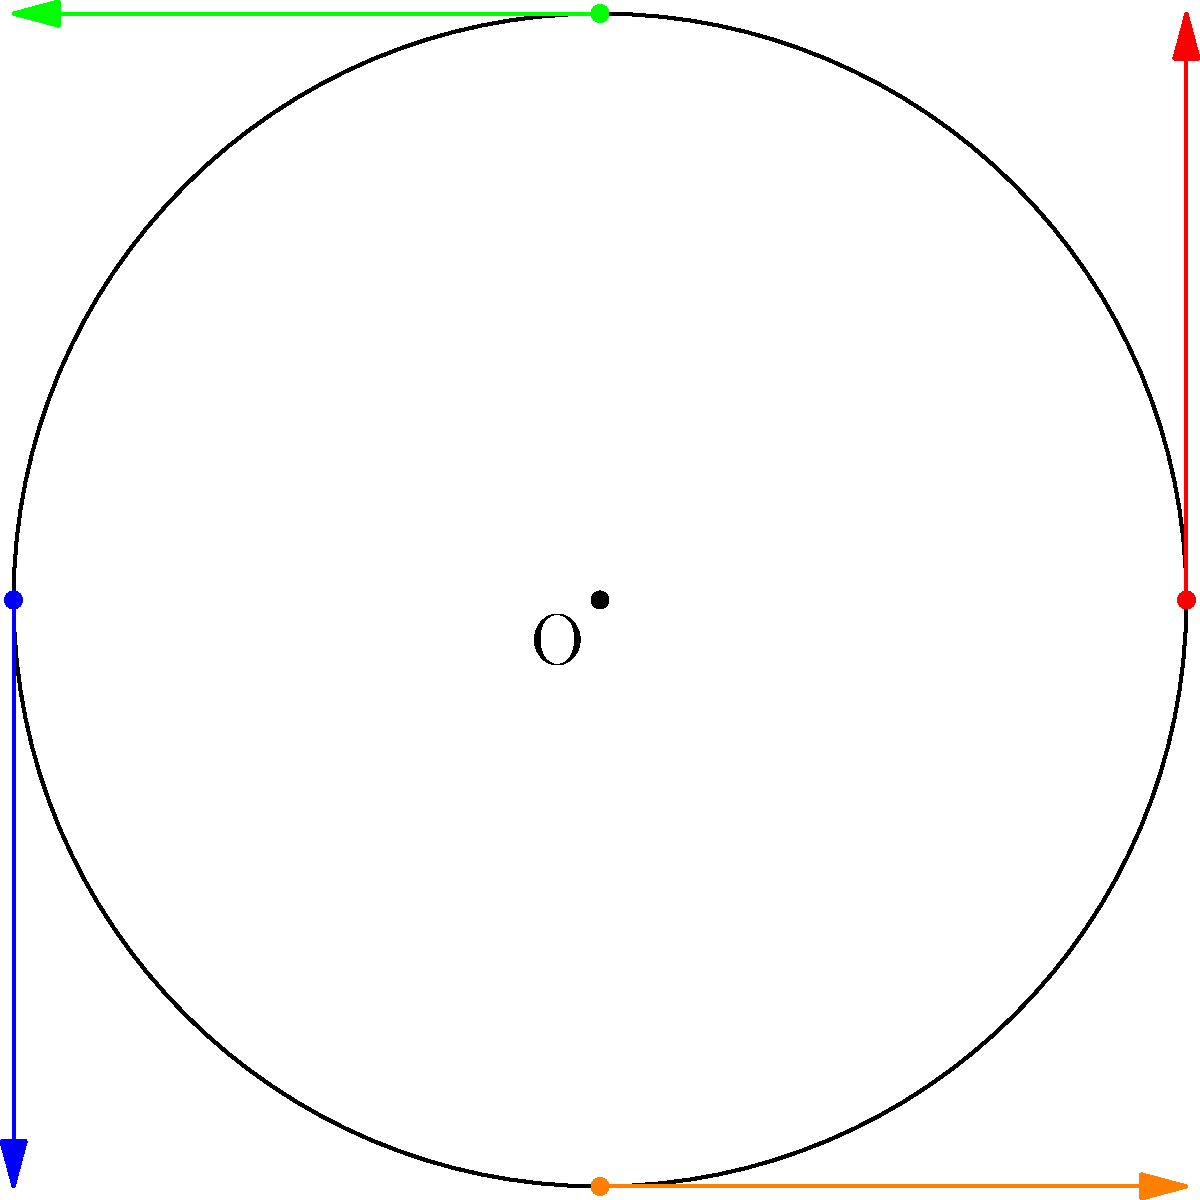Given a circle centered at the origin with radius 2, tangent lines are drawn at four points: (2,0), (0,2), (-2,0), and (0,-2). Using MATLAB, how would you efficiently plot these tangent lines and the circle in a single figure? To plot the circle and tangent lines efficiently in MATLAB, we can follow these steps:

1. Define the circle:
   $$\theta = 0:0.01:2\pi;$$
   $$x = 2 \cos(\theta);$$
   $$y = 2 \sin(\theta);$$

2. Plot the circle:
   ```matlab
   plot(x, y, 'k');
   hold on;
   axis equal;
   ```

3. Define the points where tangent lines are to be drawn:
   ```matlab
   points = [2 0; 0 2; -2 0; 0 -2];
   ```

4. Calculate tangent vectors:
   For each point $(x,y)$, the tangent vector is $(-y, x)$.
   ```matlab
   tangents = [-points(:,2), points(:,1)];
   ```

5. Plot tangent lines:
   ```matlab
   colors = ['r', 'g', 'b', 'm'];
   for i = 1:4
       p = points(i,:);
       t = tangents(i,:);
       quiver(p(1), p(2), t(1), t(2), 'Color', colors(i), 'MaxHeadSize', 0.5);
   end
   ```

6. Add labels and title:
   ```matlab
   xlabel('x');
   ylabel('y');
   title('Circle with Tangent Lines');
   legend('Circle', 'Tangent Lines');
   ```

This approach uses vectorization and efficient MATLAB functions like `quiver` to plot the tangent lines, making it suitable for large-scale data analysis workflows.
Answer: Use `plot` for circle, `quiver` for tangent lines with vectorized calculations. 